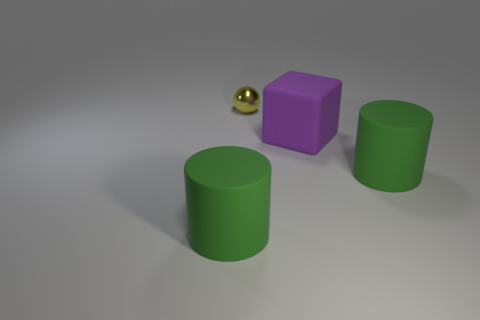Add 2 shiny objects. How many objects exist? 6 Subtract all spheres. How many objects are left? 3 Subtract 0 brown cubes. How many objects are left? 4 Subtract all gray balls. Subtract all small yellow shiny spheres. How many objects are left? 3 Add 3 small yellow balls. How many small yellow balls are left? 4 Add 2 small metal spheres. How many small metal spheres exist? 3 